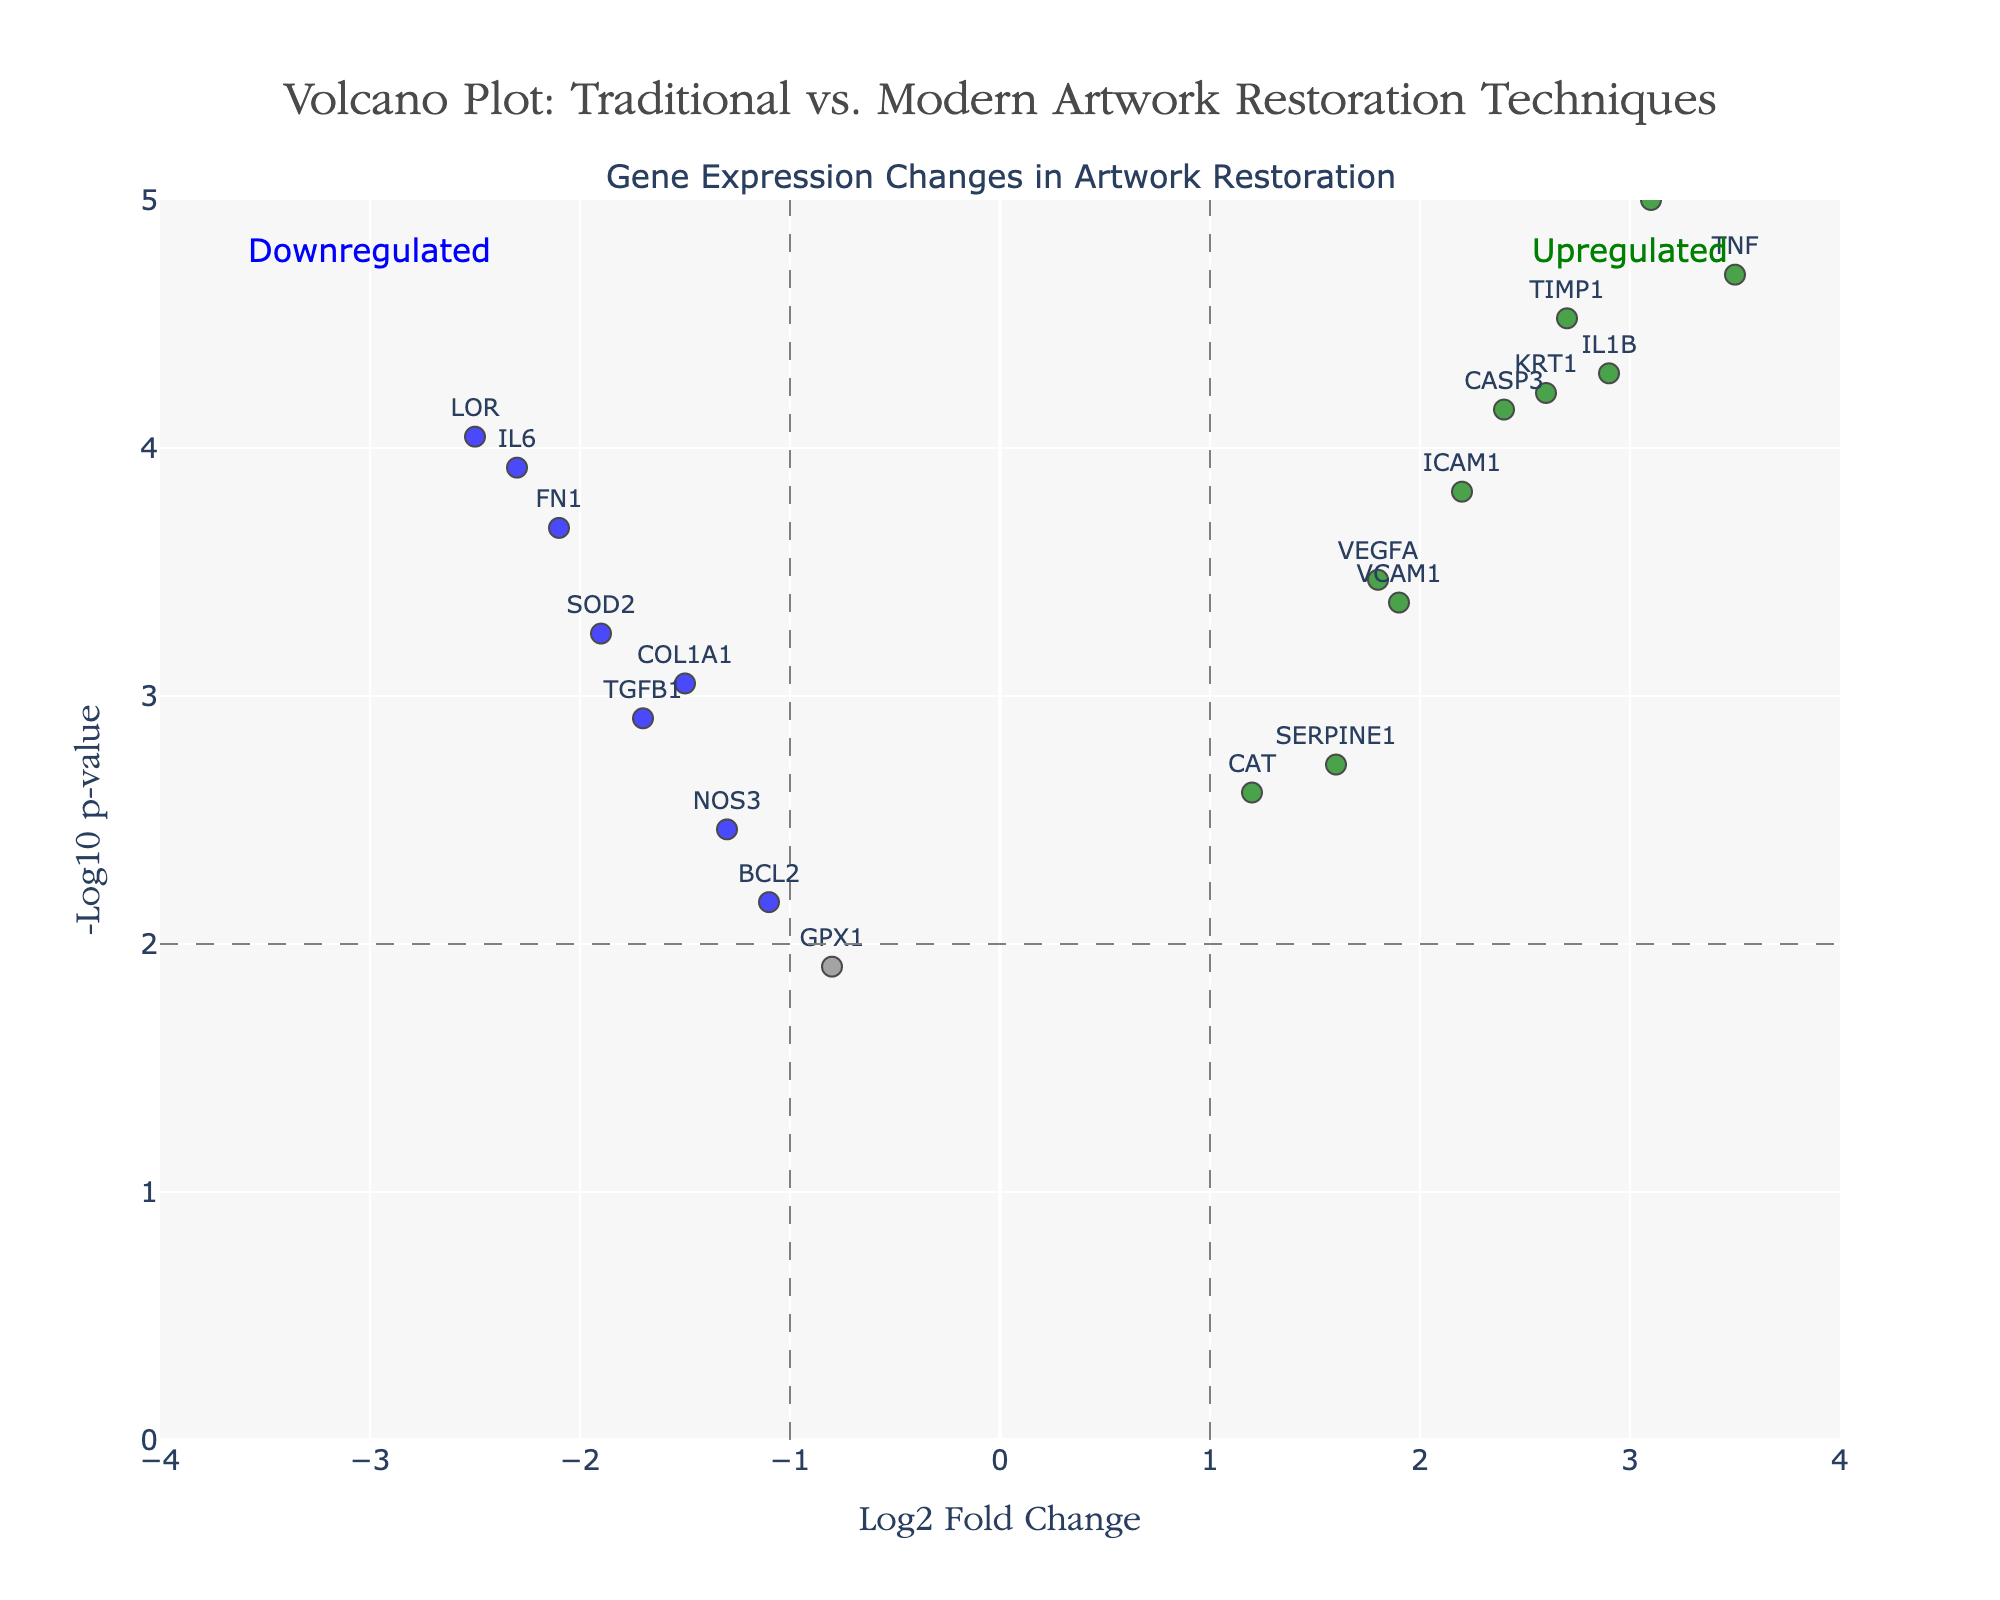What is the title of the plot? The title of the plot is usually displayed at the top of the figure, specifying the subject and context of the data visualization. Here, it reads "Volcano Plot: Traditional vs. Modern Artwork Restoration Techniques".
Answer: Volcano Plot: Traditional vs. Modern Artwork Restoration Techniques What do the x-axis and y-axis represent in the plot? The x-axis represents the Log2 Fold Change, which shows the logarithmic fold change in gene expression between traditional and modern methods. The y-axis represents the -Log10 p-value, indicating the statistical significance of the gene expression changes. This information is provided by the axis titles.
Answer: Log2 Fold Change and -Log10 p-value Which color indicates upregulated genes in the plot? In the figure, upregulated genes are marked in green color. This can be inferred from the example annotations and color legend.
Answer: green How many genes are significantly upregulated according to the figure? To determine the number of significantly upregulated genes, count the green data points. These are the genes that meet both the fold change and p-value thresholds.
Answer: 7 Which gene shows the highest level of upregulation? Identify the data point with the highest Log2 Fold Change value (farthest to the right) among the green data points. The hover information or labels can help confirm that TNF has the highest fold change.
Answer: TNF Are there more upregulated or downregulated genes with significant changes? Count the significant upregulated (green) and downregulated (blue) genes, then compare their numbers. There are 7 upregulated genes and 6 downregulated genes, making upregulated genes more prevalent.
Answer: More upregulated Which gene has the lowest p-value among those that are significantly upregulated? Among the green data points, find the one with the highest -Log10 p-value (farthest up along the y-axis), and check the hover information or data label for its p-value. MMP9 appears to have the lowest p-value.
Answer: MMP9 Compare the expression changes of IL6 and TNF. Which is more significant and by how much? Compare the -Log10 p-values of IL6 and TNF. IL6 has a -Log10 p-value of around 3.92, and TNF has around 4.70. Subtract 3.92 from 4.70 to find the difference, which is 0.78.
Answer: TNF is more significant by 0.78 Which gene has the highest intensity change but is not statistically significant? Look for the grey data point that is farthest from the center along the x-axis, meaning the highest Log2 Fold Change without meeting the significance threshold indicated by color. GPX1 fits this description.
Answer: GPX1 What are the log2 fold change and p-value for KRT1? Use the hover information or text labels on the KRT1 data point to read off the values for Log2 Fold Change and p-value. KRT1 has a Log2 Fold Change of 2.6 and a p-value of 0.00006.
Answer: Log2 Fold Change: 2.6, p-value: 0.00006 